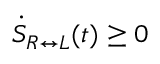<formula> <loc_0><loc_0><loc_500><loc_500>\dot { S } _ { R \leftrightarrow L } ( t ) \geq 0</formula> 